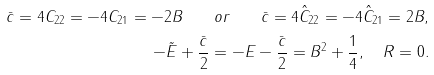<formula> <loc_0><loc_0><loc_500><loc_500>\bar { c } = 4 C _ { 2 2 } = - 4 C _ { 2 1 } = - 2 B \quad o r \quad \bar { c } = 4 \hat { C } _ { 2 2 } = - 4 \hat { C } _ { 2 1 } = 2 B , \\ - \tilde { E } + \frac { \bar { c } } { 2 } = - E - \frac { \bar { c } } { 2 } = B ^ { 2 } + \frac { 1 } { 4 } , \quad R = 0 .</formula> 